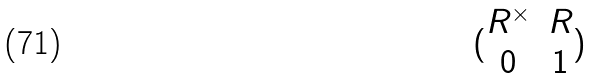Convert formula to latex. <formula><loc_0><loc_0><loc_500><loc_500>( \begin{matrix} R ^ { \times } & R \\ 0 & 1 \end{matrix} )</formula> 